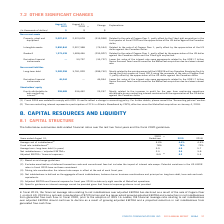According to Cogeco's financial document, How many months of MetroCast operations are included in 2018? According to the financial document, eight months. The relevant text states: "nancial expense for fiscal year 2018 include only eight months of MetroCast operations...." Also, How much was the net cash consideration in 2019? According to the financial document, $720 million. The relevant text states: "on April 30, 2019 for a net cash consideration of $720 million and to a lesser extent growing adjusted EBITDA and a reduction in net indebtedness from generated fr..." Also, What is the company's projection for EBITDA? EBITDA should continue to decline as a result of growing adjusted EBITDA and a projected reduction in net indebtedness from generated free cash flow.. The document states: "e ratio relating to net indebtedness over adjusted EBITDA should continue to decline as a result of growing adjusted EBITDA and a projected reduction ..." Also, can you calculate: What was the increase / (decrease) in the Average cost of indebtedness from 2019 to 2020? I cannot find a specific answer to this question in the financial document. Also, can you calculate: What was the average Net indebtedness / adjusted EBITDA for Fiscal 2019 and 2020? To answer this question, I need to perform calculations using the financial data. The calculation is: (2.3 + 2.6) / 2, which equals 2.45 (percentage). This is based on the information: "Net indebtedness (4) / adjusted EBITDA (5) 2.3 2.6 3.8 Net indebtedness (4) / adjusted EBITDA (5) 2.3 2.6 3.8..." The key data points involved are: 2.3, 2.6. Also, can you calculate: What was the increase / (decrease) in the Average term: long-term debt (in years) from 2018 to 2019? Based on the calculation: 4.9 - 5.7, the result is -0.8 (percentage). This is based on the information: "Average term: long-term debt (in years) 3.9 4.9 5.7 Average term: long-term debt (in years) 3.9 4.9 5.7..." The key data points involved are: 4.9, 5.7. 